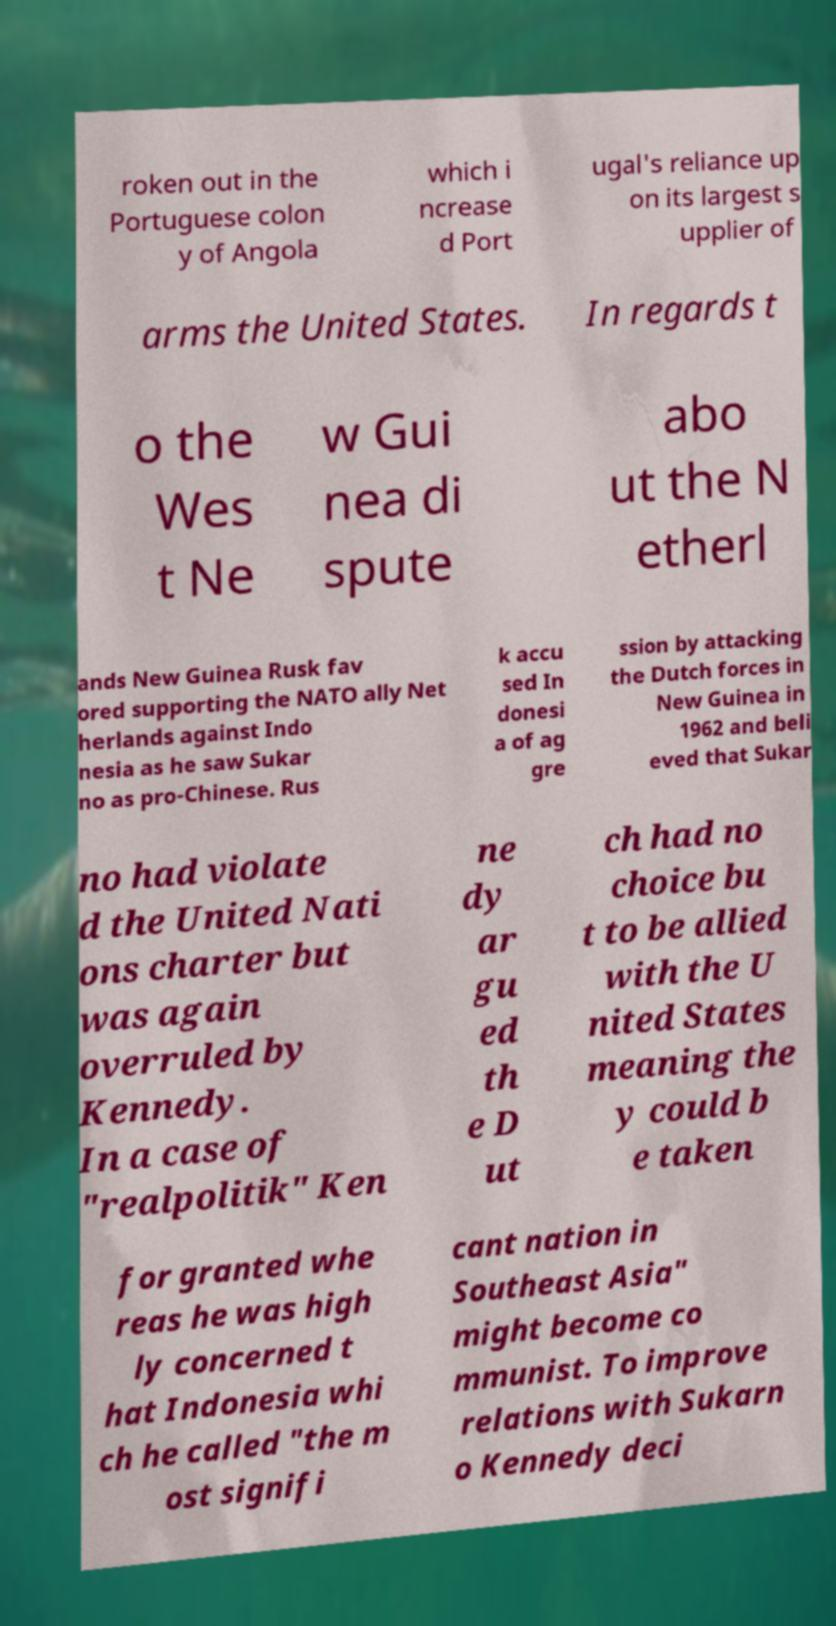Can you accurately transcribe the text from the provided image for me? roken out in the Portuguese colon y of Angola which i ncrease d Port ugal's reliance up on its largest s upplier of arms the United States. In regards t o the Wes t Ne w Gui nea di spute abo ut the N etherl ands New Guinea Rusk fav ored supporting the NATO ally Net herlands against Indo nesia as he saw Sukar no as pro-Chinese. Rus k accu sed In donesi a of ag gre ssion by attacking the Dutch forces in New Guinea in 1962 and beli eved that Sukar no had violate d the United Nati ons charter but was again overruled by Kennedy. In a case of "realpolitik" Ken ne dy ar gu ed th e D ut ch had no choice bu t to be allied with the U nited States meaning the y could b e taken for granted whe reas he was high ly concerned t hat Indonesia whi ch he called "the m ost signifi cant nation in Southeast Asia" might become co mmunist. To improve relations with Sukarn o Kennedy deci 